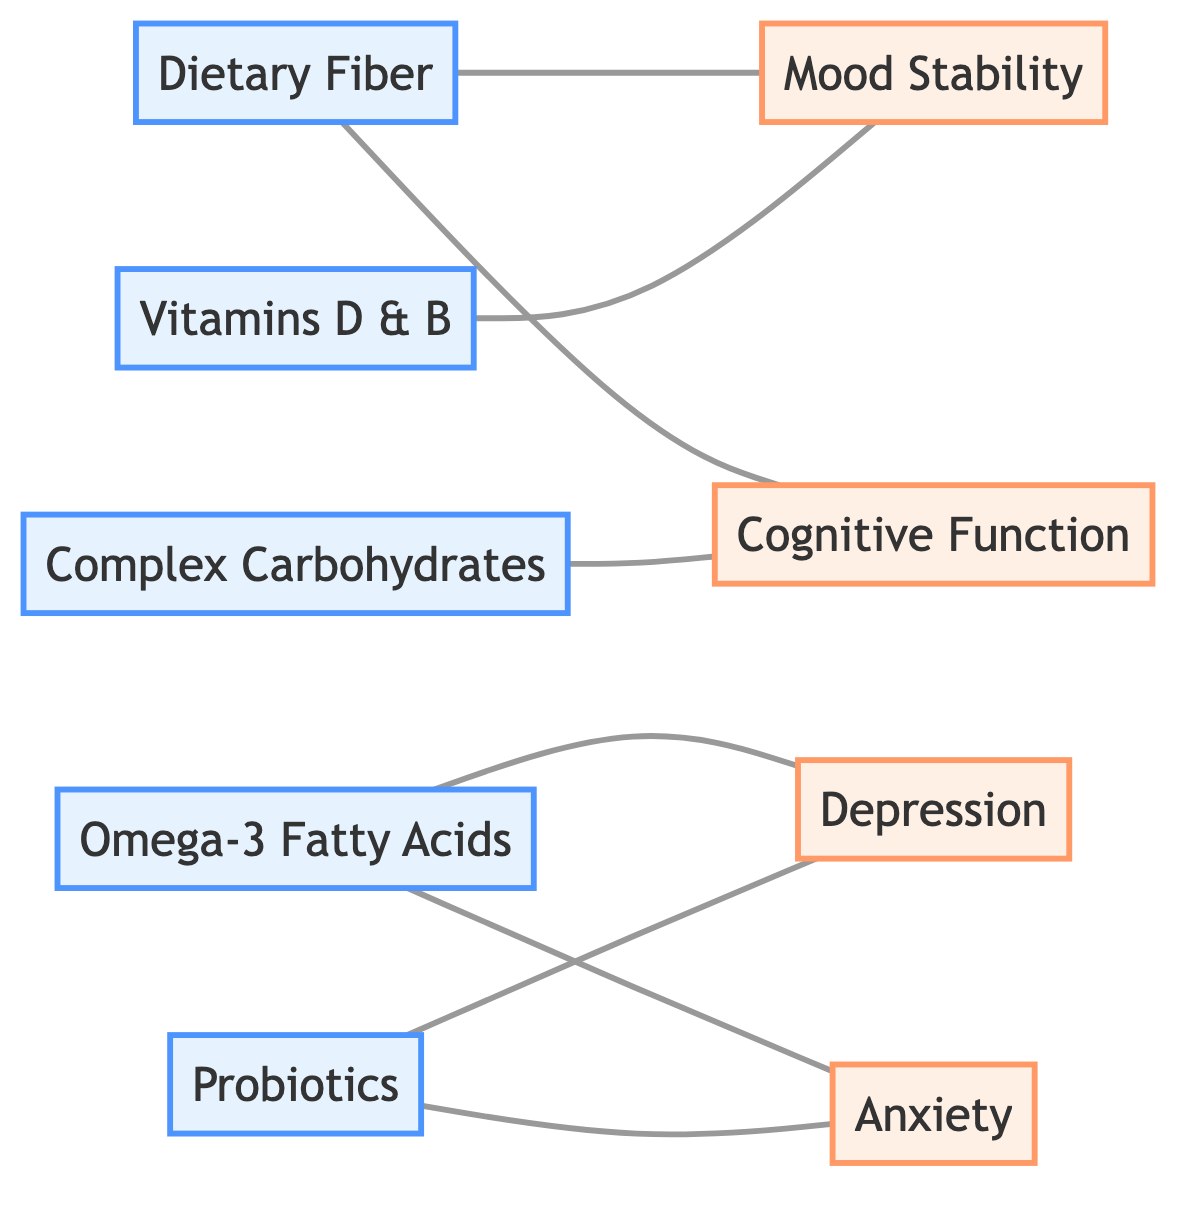What's the total number of dietary elements in the diagram? The diagram lists five distinct nodes under the category of dietary elements: Dietary Fiber, Omega-3 Fatty Acids, Complex Carbohydrates, Vitamins D & B, and Probiotics.
Answer: 5 Which mental health factor is improved by Dietary Fiber? The link between Dietary Fiber and Mood Stability indicates that Dietary Fiber improves Mood Stability as per the information in the diagram.
Answer: Mood Stability How many edges connect Probiotics to mental health factors? Probiotics is linked to two mental health factors: Anxiety and Depression. Therefore, it has a total of two edges connecting it to these factors.
Answer: 2 Which dietary element enhances Cognitive Function? The relationship is clearly stated in the diagram, showing that Complex Carbohydrates enhance Cognitive Function.
Answer: Complex Carbohydrates What type of relationship exists between Omega-3 Fatty Acids and Anxiety? The diagram shows that Omega-3 Fatty Acids reduce Anxiety, indicating a negative impact on its levels.
Answer: reduces Which dietary element supports Cognitive Function, according to the diagram? The link establishes that Dietary Fiber supports Cognitive Function, as indicated by the connection in the diagram.
Answer: Dietary Fiber Name the mental health factor that is alleviated by Probiotics. The links in the diagram show that Probiotics alleviate both Anxiety and Depression; thus, either of these can be an answer.
Answer: Anxiety How many relationships involving Vitamins D & B are represented in the diagram? The diagram illustrates that Vitamins D & B has one relationship with Mood Stability, so there is only one link involving this dietary element.
Answer: 1 Which dietary element has the most connections to mental health factors? By examining the links, the most connected dietary element is Omega-3 Fatty Acids, with connections to both Depression and Anxiety, totaling two connections.
Answer: Omega-3 Fatty Acids 